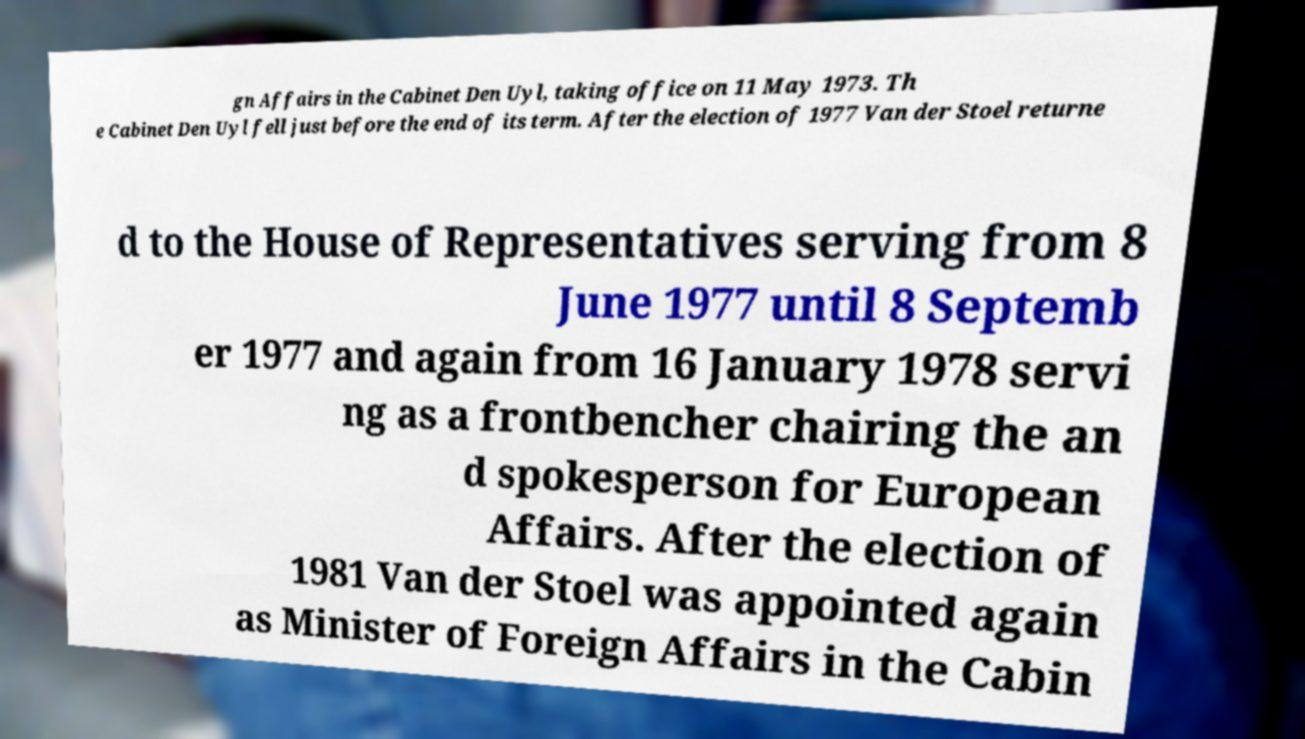What messages or text are displayed in this image? I need them in a readable, typed format. gn Affairs in the Cabinet Den Uyl, taking office on 11 May 1973. Th e Cabinet Den Uyl fell just before the end of its term. After the election of 1977 Van der Stoel returne d to the House of Representatives serving from 8 June 1977 until 8 Septemb er 1977 and again from 16 January 1978 servi ng as a frontbencher chairing the an d spokesperson for European Affairs. After the election of 1981 Van der Stoel was appointed again as Minister of Foreign Affairs in the Cabin 